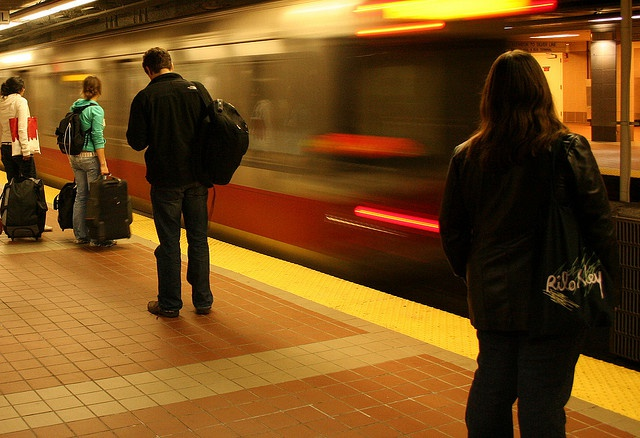Describe the objects in this image and their specific colors. I can see train in maroon, black, and olive tones, people in maroon, black, olive, and brown tones, people in maroon, black, and olive tones, backpack in maroon, black, and olive tones, and handbag in maroon, black, and olive tones in this image. 